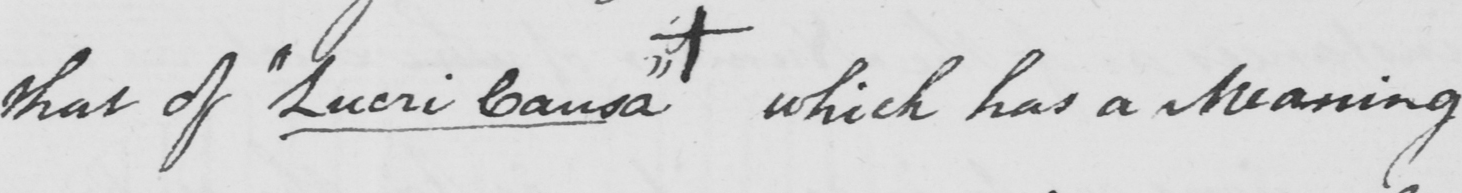Transcribe the text shown in this historical manuscript line. that of  " Lucri Causa "  +  which has a meaning 